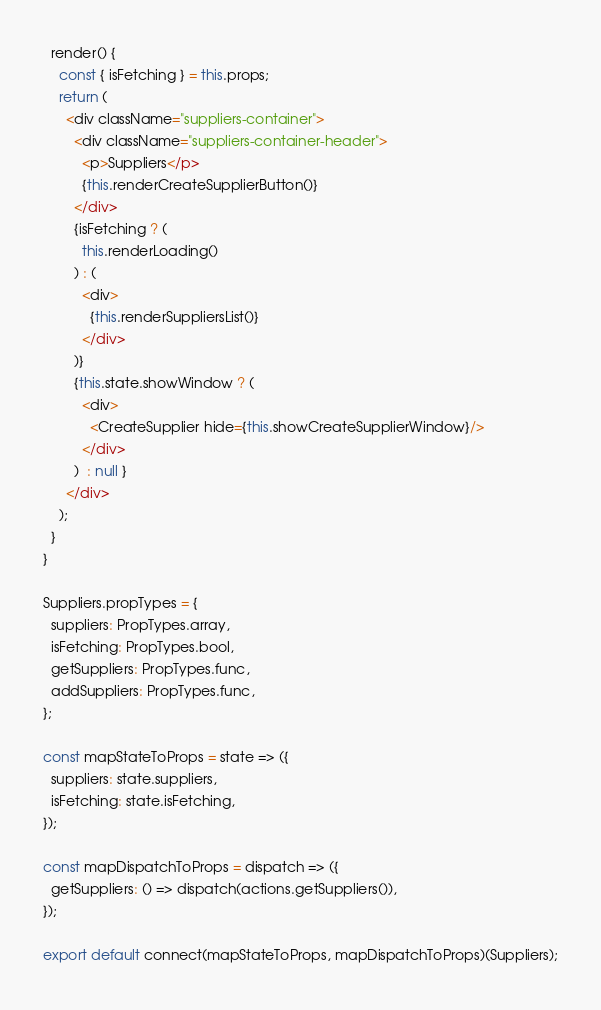Convert code to text. <code><loc_0><loc_0><loc_500><loc_500><_JavaScript_>
  render() {
    const { isFetching } = this.props;
    return (
      <div className="suppliers-container">
        <div className="suppliers-container-header">
          <p>Suppliers</p>
          {this.renderCreateSupplierButton()}
        </div>
        {isFetching ? (
          this.renderLoading()
        ) : (
          <div>
            {this.renderSuppliersList()}
          </div>
        )}
        {this.state.showWindow ? (
          <div>
            <CreateSupplier hide={this.showCreateSupplierWindow}/>
          </div>
        )  : null }
      </div>
    );
  }
}

Suppliers.propTypes = {
  suppliers: PropTypes.array,
  isFetching: PropTypes.bool,
  getSuppliers: PropTypes.func,
  addSuppliers: PropTypes.func,
};

const mapStateToProps = state => ({
  suppliers: state.suppliers,
  isFetching: state.isFetching,
});

const mapDispatchToProps = dispatch => ({
  getSuppliers: () => dispatch(actions.getSuppliers()),
});

export default connect(mapStateToProps, mapDispatchToProps)(Suppliers);
</code> 